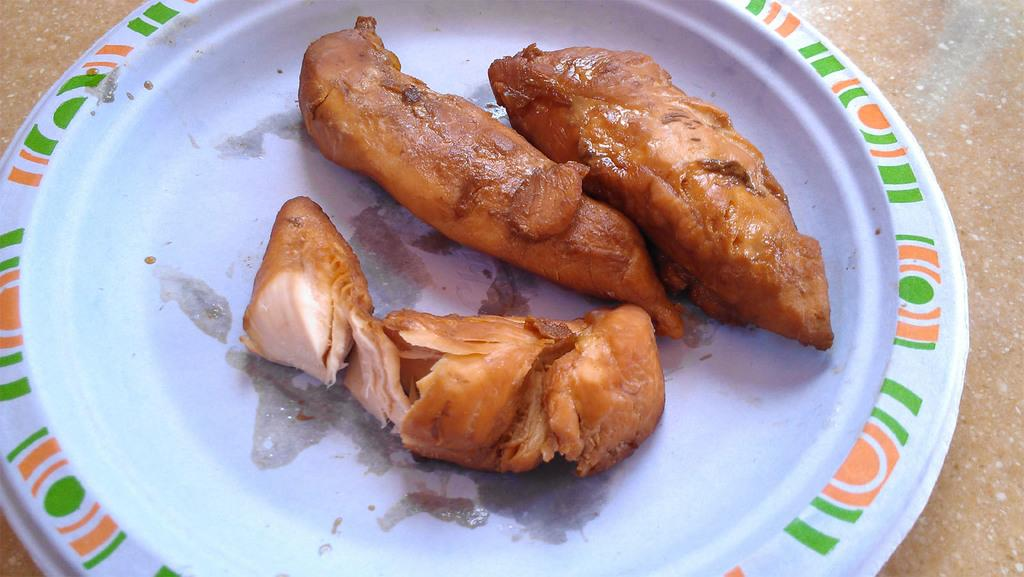What is on the plate that is visible in the image? There is meat present on the plate in the image. What might be used to serve or hold the meat on the plate? A plate is present in the image to serve or hold the meat. What type of form is being filled out during the meeting in the image? There is no meeting or form present in the image; it only features a plate with meat on it. 